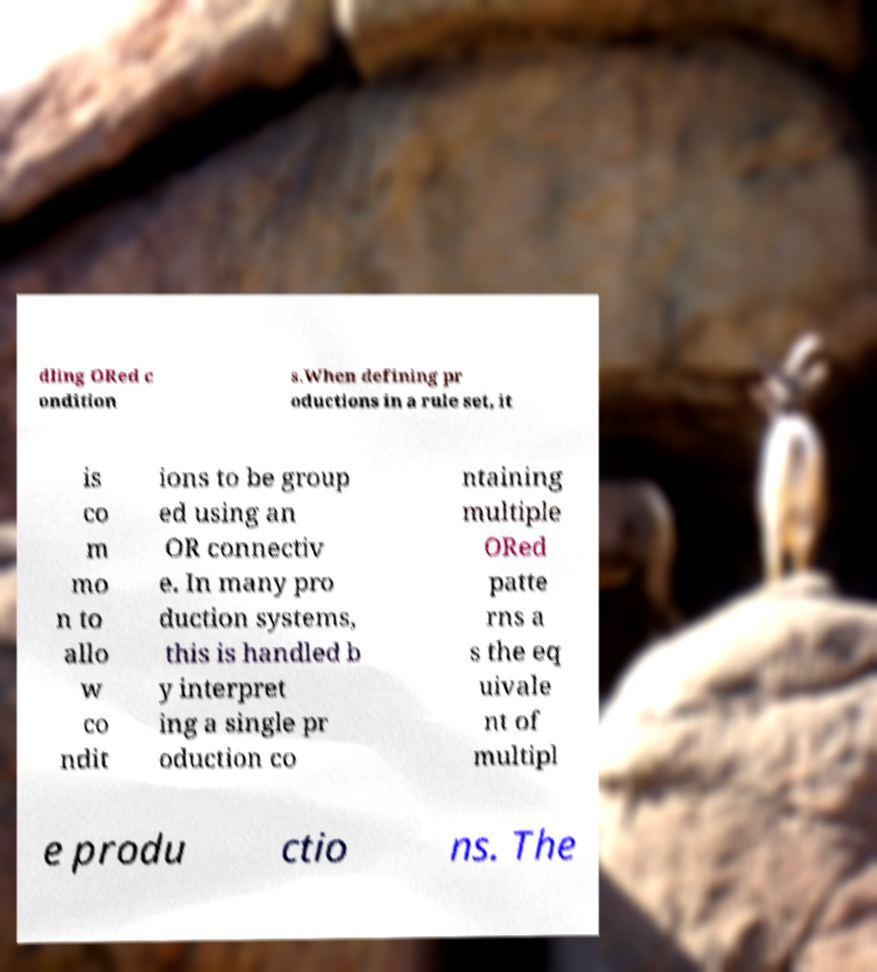Please read and relay the text visible in this image. What does it say? dling ORed c ondition s.When defining pr oductions in a rule set, it is co m mo n to allo w co ndit ions to be group ed using an OR connectiv e. In many pro duction systems, this is handled b y interpret ing a single pr oduction co ntaining multiple ORed patte rns a s the eq uivale nt of multipl e produ ctio ns. The 